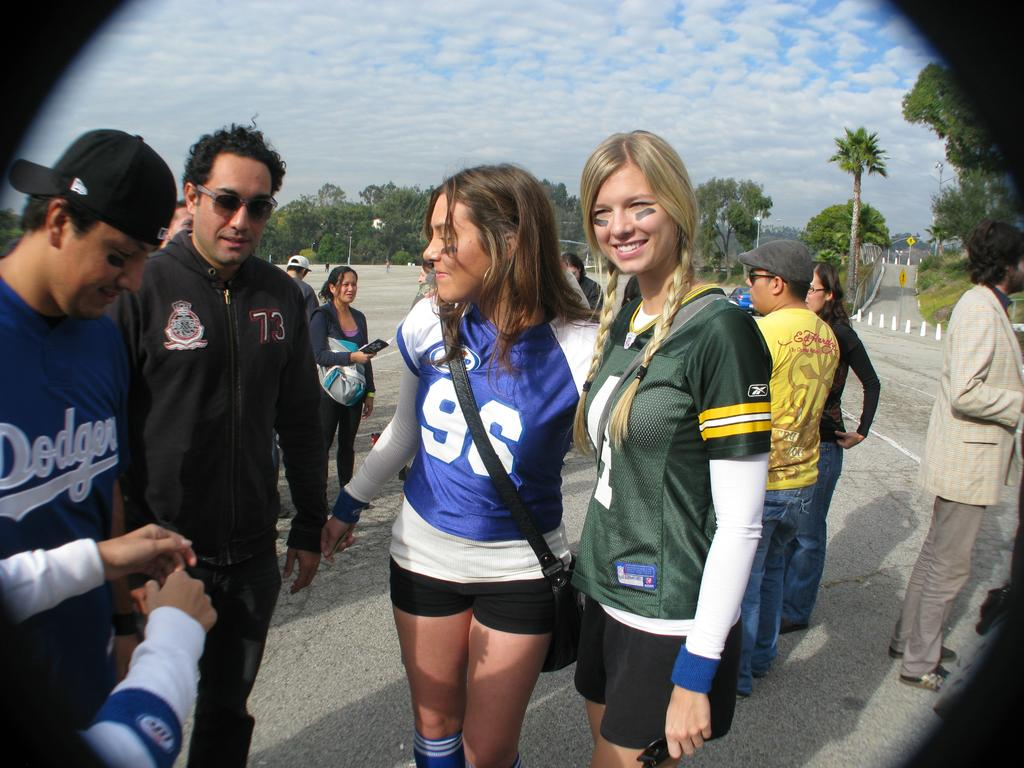<image>
Describe the image concisely. A girl has the number 96 on her jersey and is talking to others. 